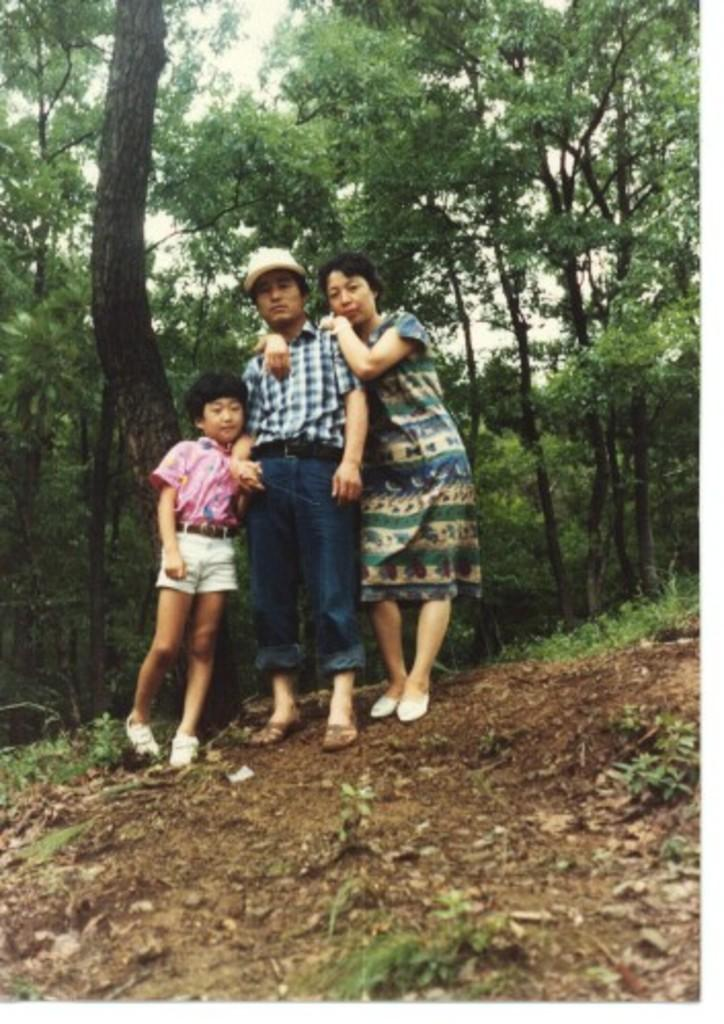How many people are present in the image? There are three people in the image. What are the people doing in the image? The people are standing on a path. What can be seen in the background of the image? There are trees and the sky visible in the background of the image. What type of angle is the can positioned at in the image? There is no can present in the image, so it is not possible to determine the angle at which it might be positioned. 